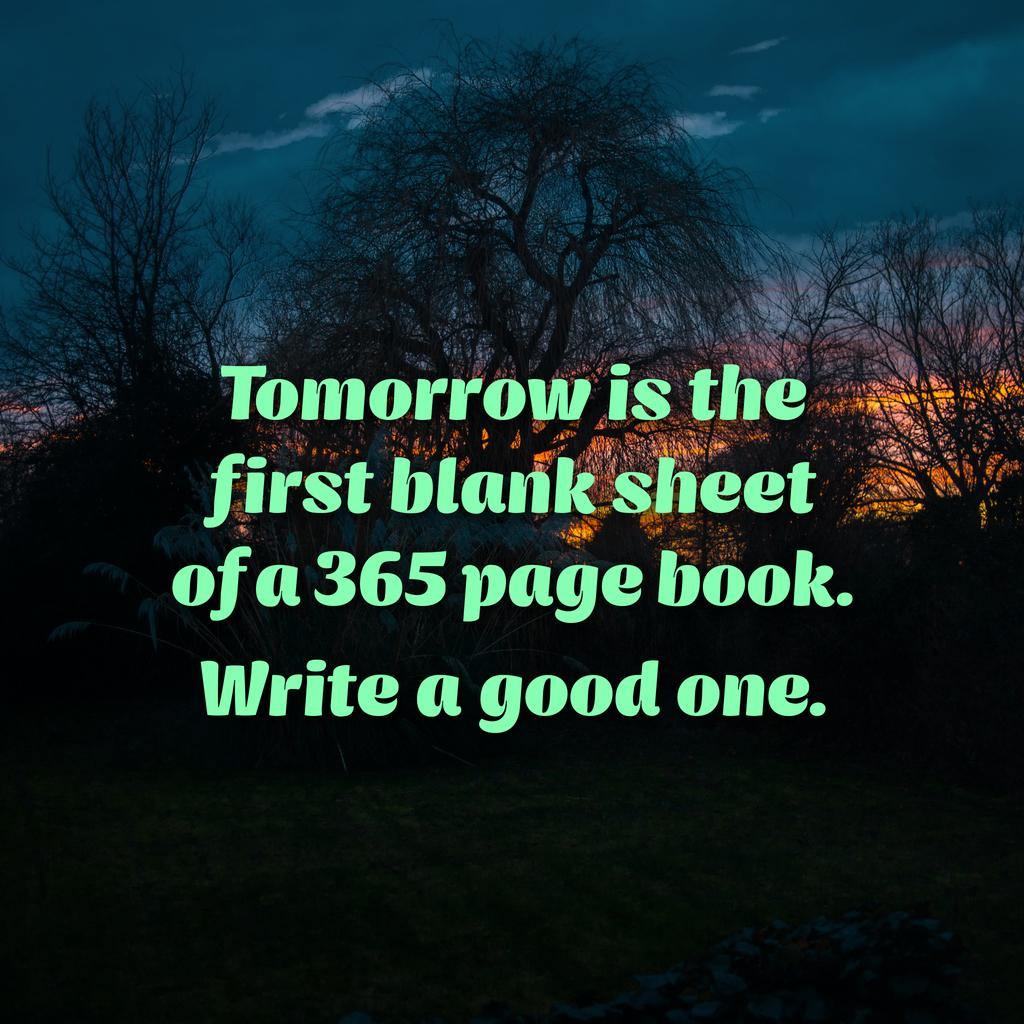What is the current state of the book in the image? There is a blank sheet of a 365-page book in the image. What is written on the blank sheet? The phrase "tomorrow is the first" is written on the blank sheet. What can be seen in the background of the image? There are dried trees in the background of the image. What type of ink is used to write on the blank sheet in the image? There is no information about the type of ink used in the image, as the focus is on the phrase written on the sheet. 